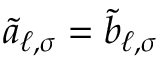Convert formula to latex. <formula><loc_0><loc_0><loc_500><loc_500>\tilde { a } _ { \ell , \sigma } = \tilde { b } _ { \ell , \sigma }</formula> 